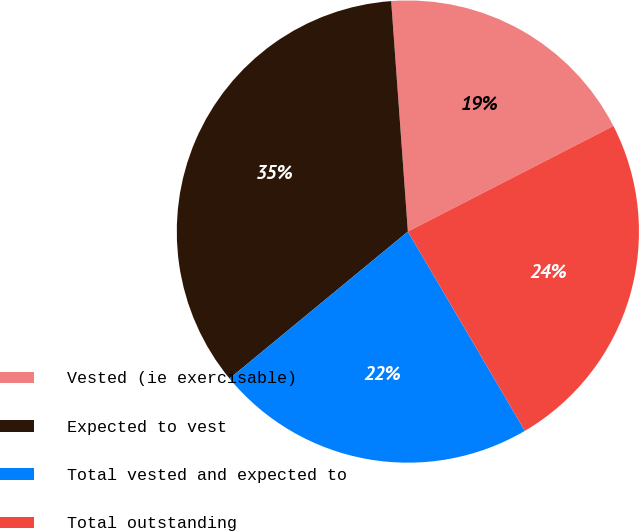<chart> <loc_0><loc_0><loc_500><loc_500><pie_chart><fcel>Vested (ie exercisable)<fcel>Expected to vest<fcel>Total vested and expected to<fcel>Total outstanding<nl><fcel>18.6%<fcel>34.82%<fcel>22.48%<fcel>24.1%<nl></chart> 